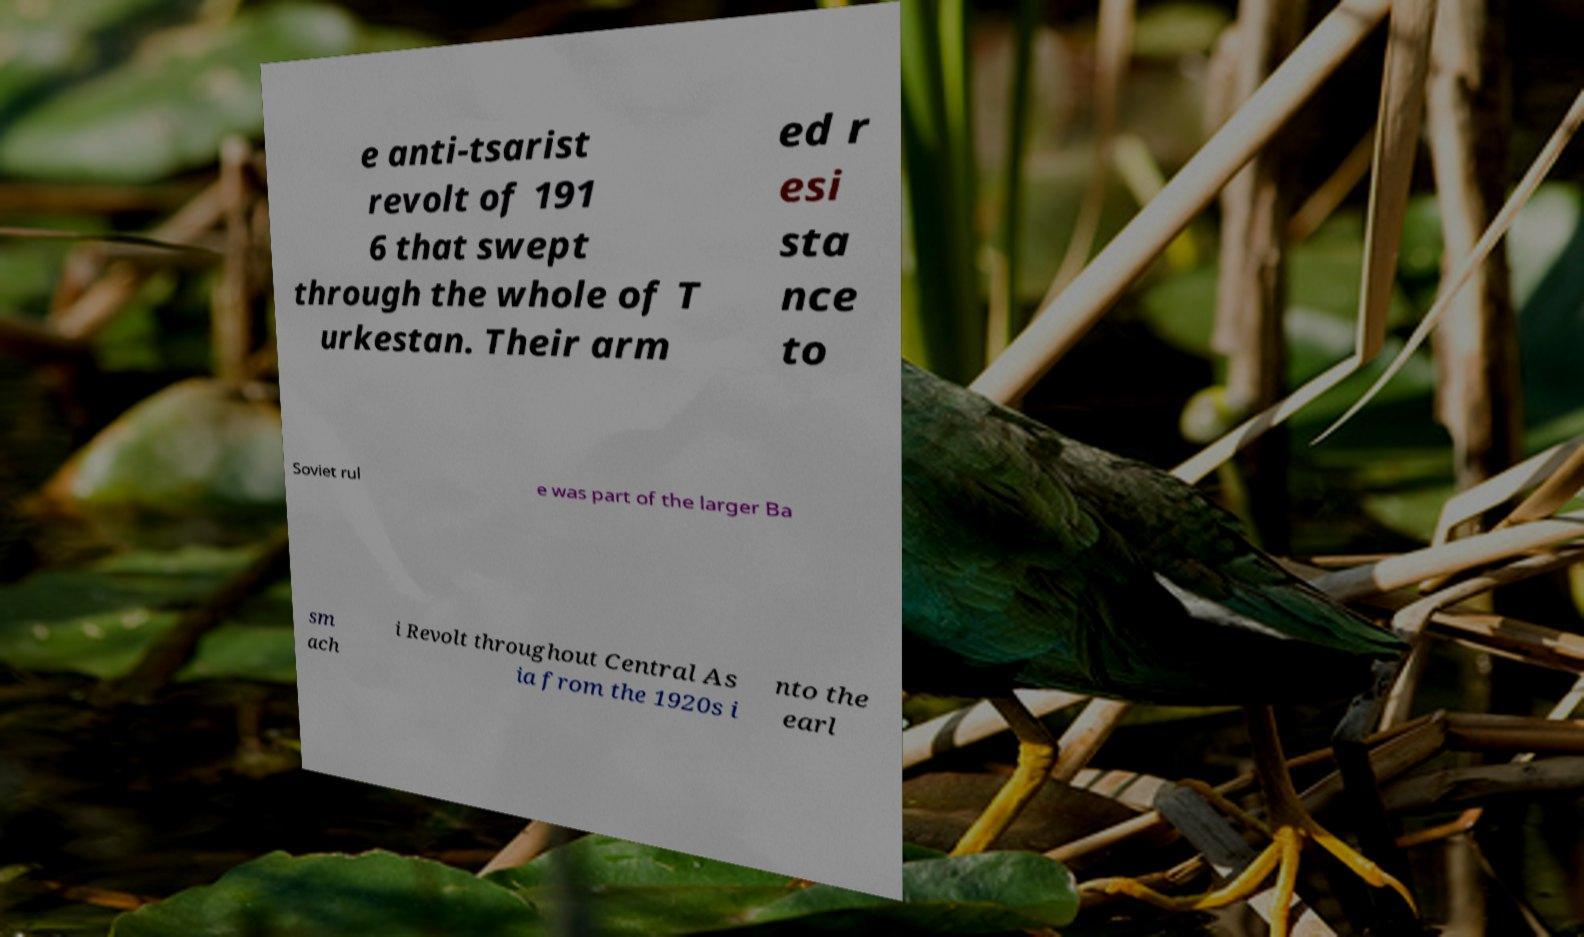For documentation purposes, I need the text within this image transcribed. Could you provide that? e anti-tsarist revolt of 191 6 that swept through the whole of T urkestan. Their arm ed r esi sta nce to Soviet rul e was part of the larger Ba sm ach i Revolt throughout Central As ia from the 1920s i nto the earl 